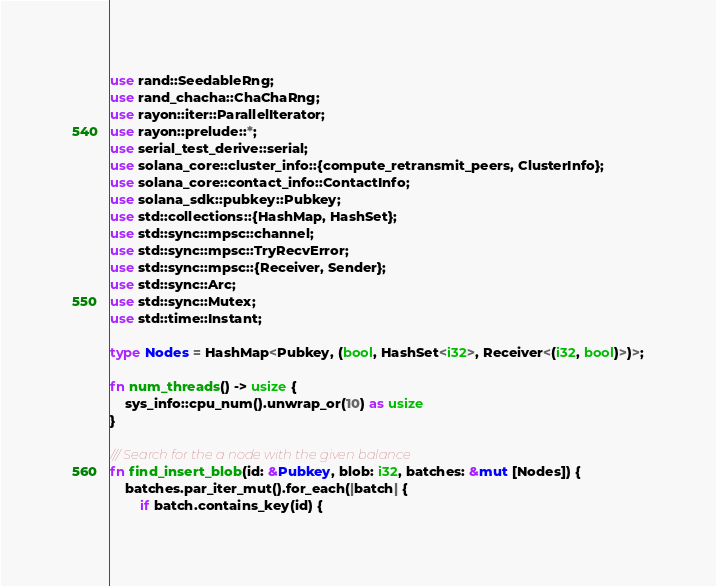Convert code to text. <code><loc_0><loc_0><loc_500><loc_500><_Rust_>use rand::SeedableRng;
use rand_chacha::ChaChaRng;
use rayon::iter::ParallelIterator;
use rayon::prelude::*;
use serial_test_derive::serial;
use solana_core::cluster_info::{compute_retransmit_peers, ClusterInfo};
use solana_core::contact_info::ContactInfo;
use solana_sdk::pubkey::Pubkey;
use std::collections::{HashMap, HashSet};
use std::sync::mpsc::channel;
use std::sync::mpsc::TryRecvError;
use std::sync::mpsc::{Receiver, Sender};
use std::sync::Arc;
use std::sync::Mutex;
use std::time::Instant;

type Nodes = HashMap<Pubkey, (bool, HashSet<i32>, Receiver<(i32, bool)>)>;

fn num_threads() -> usize {
    sys_info::cpu_num().unwrap_or(10) as usize
}

/// Search for the a node with the given balance
fn find_insert_blob(id: &Pubkey, blob: i32, batches: &mut [Nodes]) {
    batches.par_iter_mut().for_each(|batch| {
        if batch.contains_key(id) {</code> 